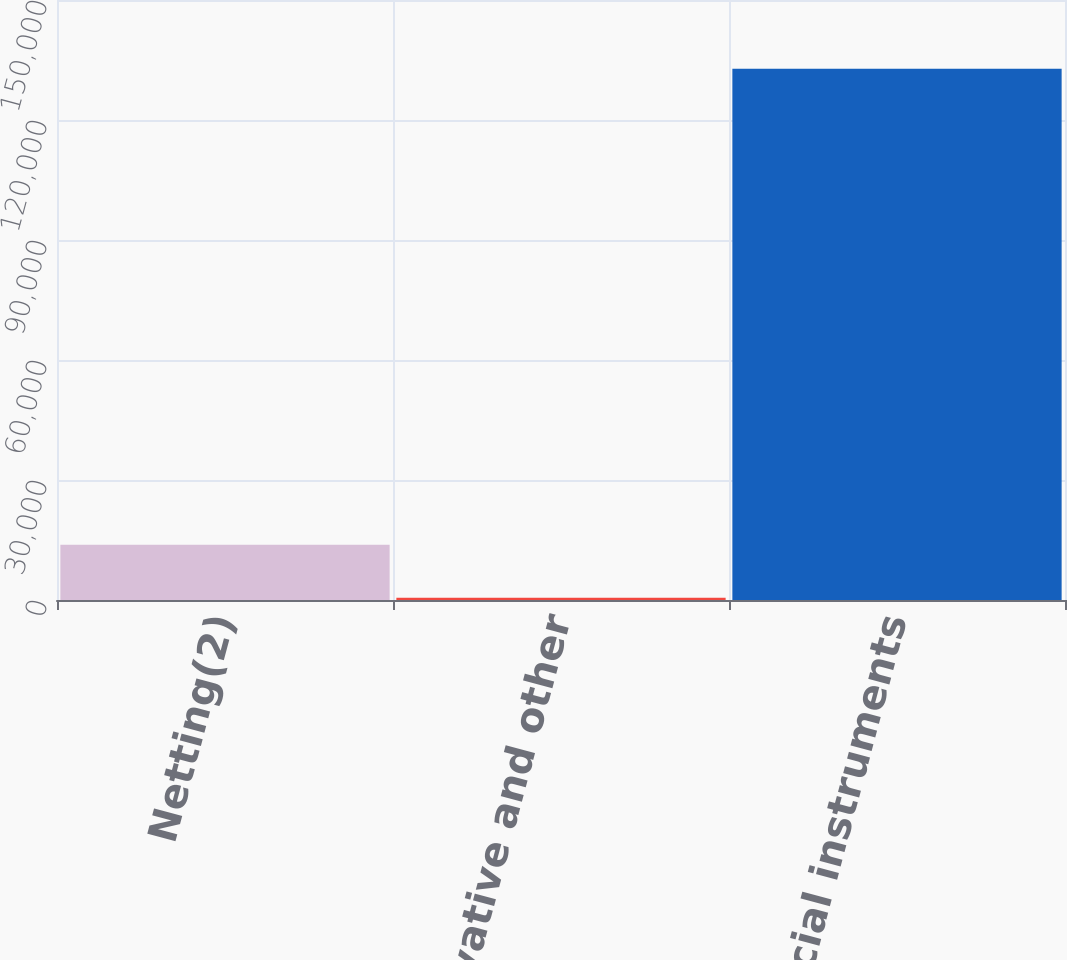Convert chart. <chart><loc_0><loc_0><loc_500><loc_500><bar_chart><fcel>Netting(2)<fcel>Total derivative and other<fcel>Total financial instruments<nl><fcel>13805.8<fcel>582<fcel>132820<nl></chart> 